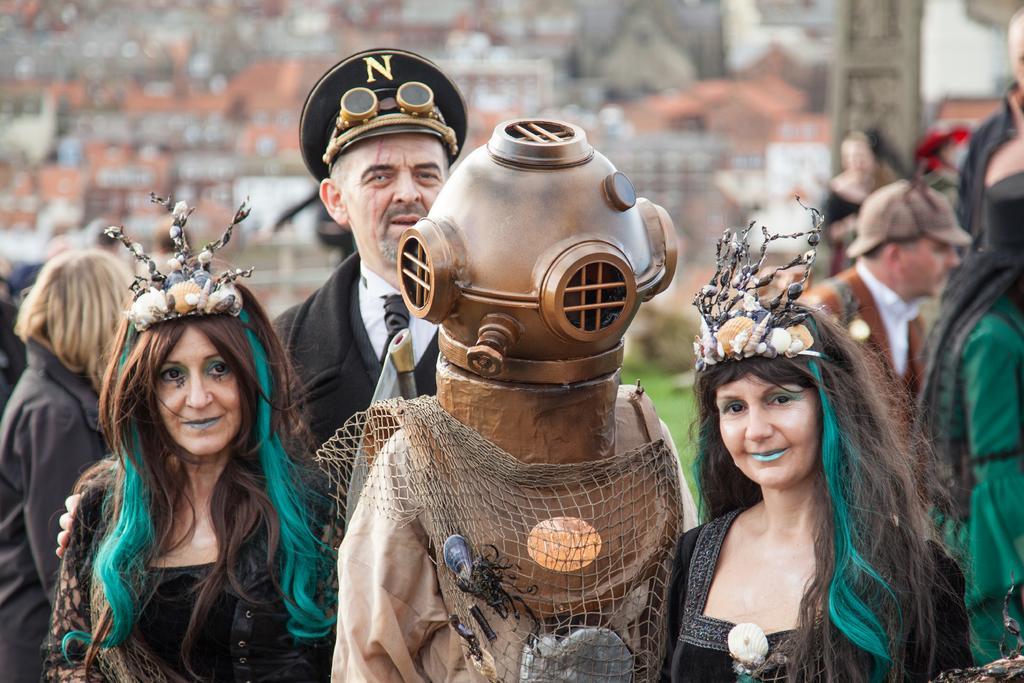Please provide a concise description of this image. In this picture we can see some people standing here, they wore costumes, in the background there is a wall, this man wore a cap, we can see grass here. 